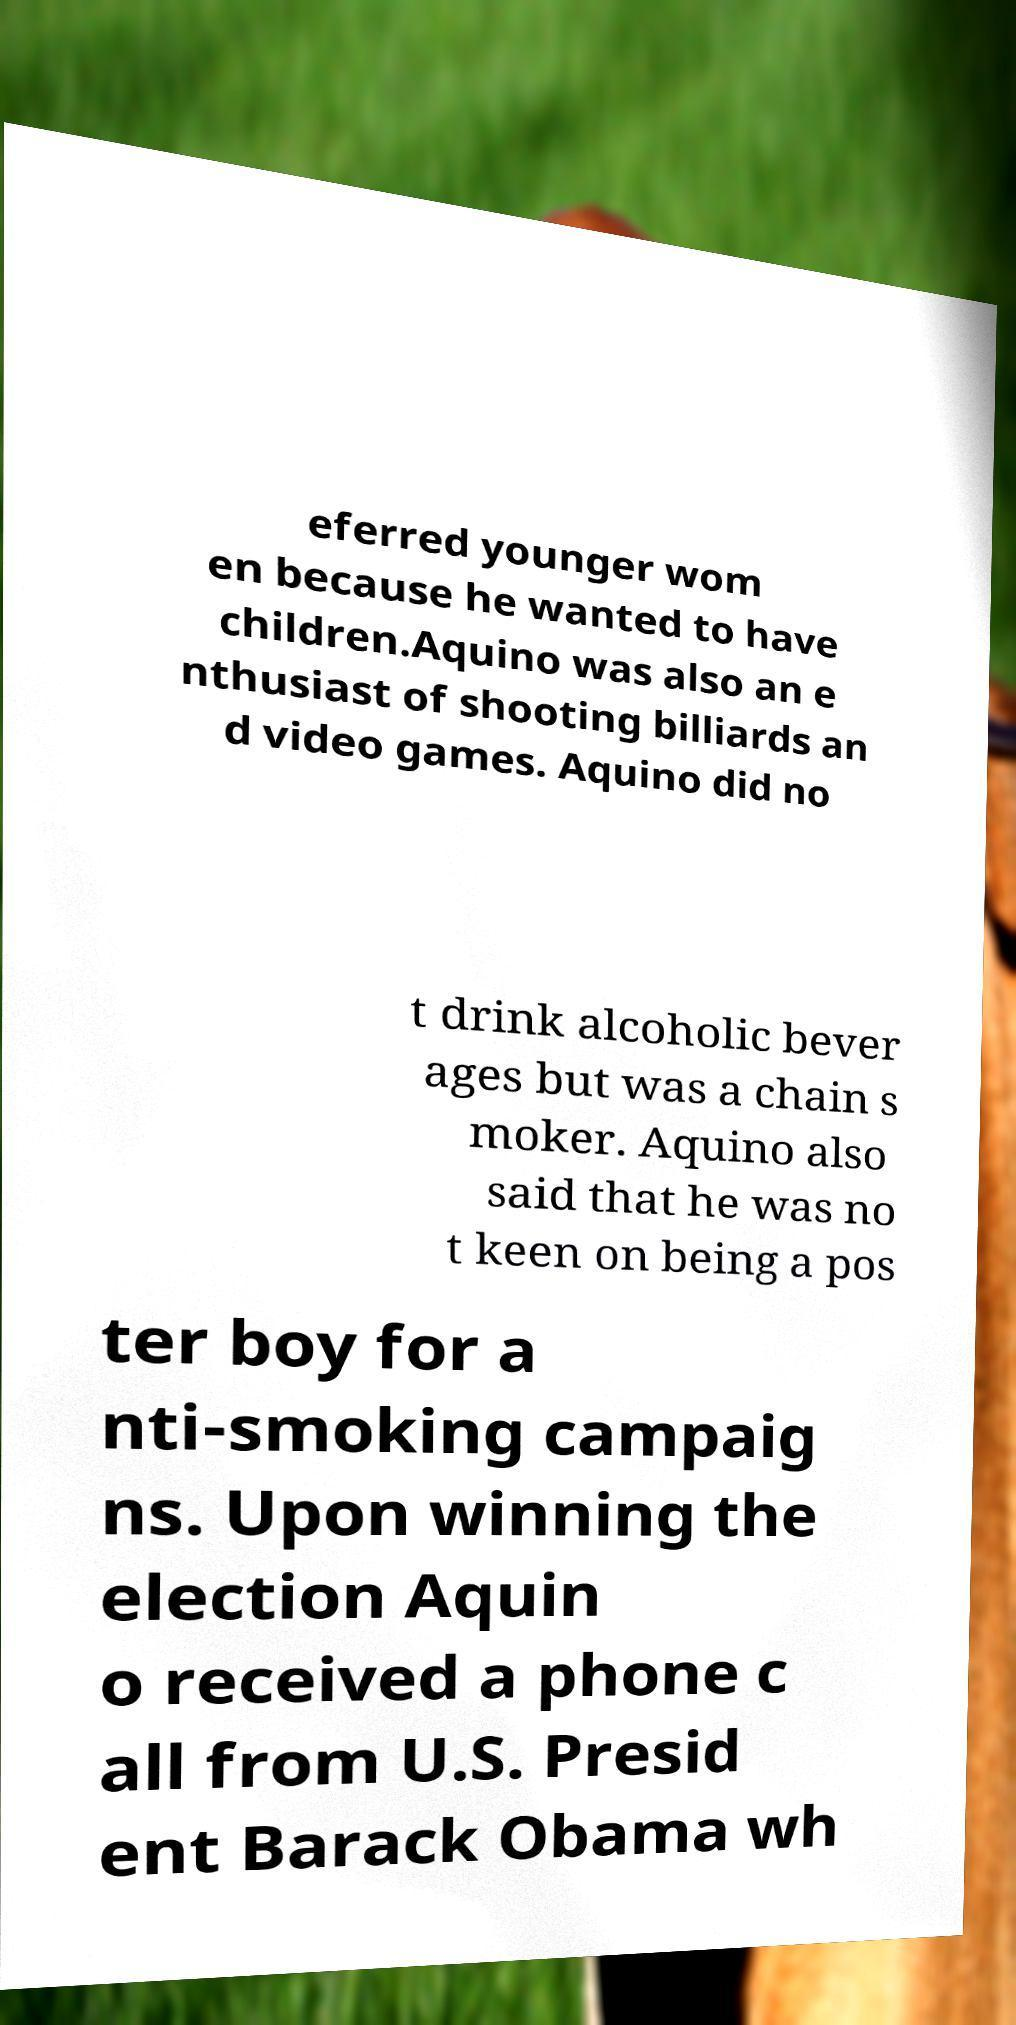For documentation purposes, I need the text within this image transcribed. Could you provide that? eferred younger wom en because he wanted to have children.Aquino was also an e nthusiast of shooting billiards an d video games. Aquino did no t drink alcoholic bever ages but was a chain s moker. Aquino also said that he was no t keen on being a pos ter boy for a nti-smoking campaig ns. Upon winning the election Aquin o received a phone c all from U.S. Presid ent Barack Obama wh 